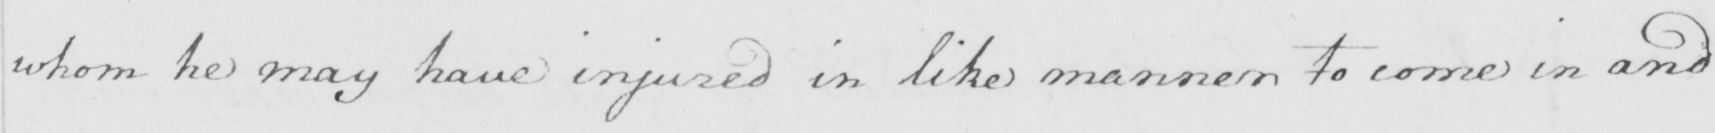Transcribe the text shown in this historical manuscript line. whom he may have injured in like manner to come in and 